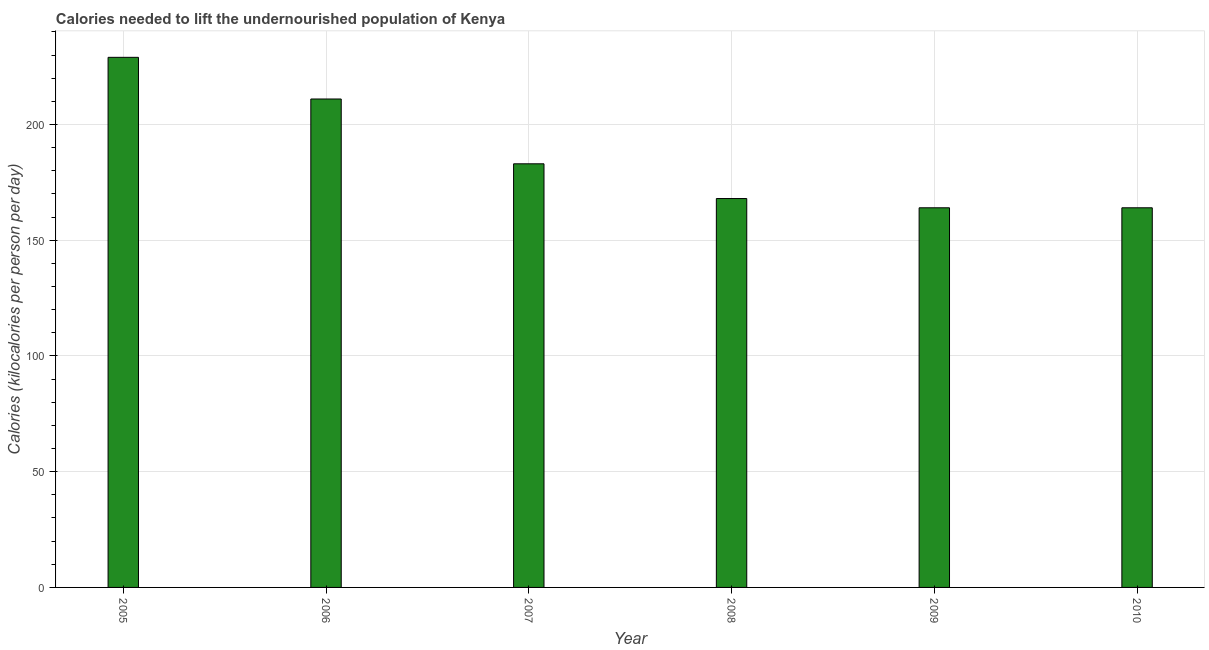Does the graph contain grids?
Make the answer very short. Yes. What is the title of the graph?
Offer a terse response. Calories needed to lift the undernourished population of Kenya. What is the label or title of the Y-axis?
Ensure brevity in your answer.  Calories (kilocalories per person per day). What is the depth of food deficit in 2007?
Provide a short and direct response. 183. Across all years, what is the maximum depth of food deficit?
Ensure brevity in your answer.  229. Across all years, what is the minimum depth of food deficit?
Offer a terse response. 164. What is the sum of the depth of food deficit?
Provide a short and direct response. 1119. What is the average depth of food deficit per year?
Make the answer very short. 186. What is the median depth of food deficit?
Give a very brief answer. 175.5. What is the ratio of the depth of food deficit in 2008 to that in 2010?
Give a very brief answer. 1.02. What is the difference between the highest and the lowest depth of food deficit?
Offer a terse response. 65. In how many years, is the depth of food deficit greater than the average depth of food deficit taken over all years?
Ensure brevity in your answer.  2. How many years are there in the graph?
Provide a succinct answer. 6. Are the values on the major ticks of Y-axis written in scientific E-notation?
Your answer should be compact. No. What is the Calories (kilocalories per person per day) in 2005?
Offer a very short reply. 229. What is the Calories (kilocalories per person per day) of 2006?
Ensure brevity in your answer.  211. What is the Calories (kilocalories per person per day) in 2007?
Give a very brief answer. 183. What is the Calories (kilocalories per person per day) in 2008?
Your response must be concise. 168. What is the Calories (kilocalories per person per day) of 2009?
Give a very brief answer. 164. What is the Calories (kilocalories per person per day) in 2010?
Ensure brevity in your answer.  164. What is the difference between the Calories (kilocalories per person per day) in 2005 and 2006?
Your answer should be compact. 18. What is the difference between the Calories (kilocalories per person per day) in 2005 and 2007?
Provide a succinct answer. 46. What is the difference between the Calories (kilocalories per person per day) in 2005 and 2008?
Provide a short and direct response. 61. What is the difference between the Calories (kilocalories per person per day) in 2005 and 2009?
Give a very brief answer. 65. What is the difference between the Calories (kilocalories per person per day) in 2006 and 2008?
Offer a very short reply. 43. What is the difference between the Calories (kilocalories per person per day) in 2006 and 2009?
Make the answer very short. 47. What is the difference between the Calories (kilocalories per person per day) in 2006 and 2010?
Make the answer very short. 47. What is the difference between the Calories (kilocalories per person per day) in 2007 and 2008?
Provide a short and direct response. 15. What is the difference between the Calories (kilocalories per person per day) in 2008 and 2009?
Offer a terse response. 4. What is the difference between the Calories (kilocalories per person per day) in 2008 and 2010?
Offer a terse response. 4. What is the ratio of the Calories (kilocalories per person per day) in 2005 to that in 2006?
Give a very brief answer. 1.08. What is the ratio of the Calories (kilocalories per person per day) in 2005 to that in 2007?
Ensure brevity in your answer.  1.25. What is the ratio of the Calories (kilocalories per person per day) in 2005 to that in 2008?
Your answer should be very brief. 1.36. What is the ratio of the Calories (kilocalories per person per day) in 2005 to that in 2009?
Your answer should be compact. 1.4. What is the ratio of the Calories (kilocalories per person per day) in 2005 to that in 2010?
Offer a very short reply. 1.4. What is the ratio of the Calories (kilocalories per person per day) in 2006 to that in 2007?
Provide a short and direct response. 1.15. What is the ratio of the Calories (kilocalories per person per day) in 2006 to that in 2008?
Give a very brief answer. 1.26. What is the ratio of the Calories (kilocalories per person per day) in 2006 to that in 2009?
Keep it short and to the point. 1.29. What is the ratio of the Calories (kilocalories per person per day) in 2006 to that in 2010?
Give a very brief answer. 1.29. What is the ratio of the Calories (kilocalories per person per day) in 2007 to that in 2008?
Make the answer very short. 1.09. What is the ratio of the Calories (kilocalories per person per day) in 2007 to that in 2009?
Offer a very short reply. 1.12. What is the ratio of the Calories (kilocalories per person per day) in 2007 to that in 2010?
Make the answer very short. 1.12. What is the ratio of the Calories (kilocalories per person per day) in 2008 to that in 2010?
Give a very brief answer. 1.02. 